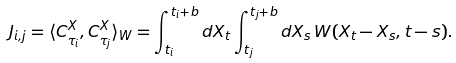<formula> <loc_0><loc_0><loc_500><loc_500>\ J _ { i , j } = \langle C ^ { X } _ { \tau _ { i } } , C ^ { X } _ { \tau _ { j } } \rangle _ { W } = \int _ { t _ { i } } ^ { t _ { i } + b } d X _ { t } \int _ { t _ { j } } ^ { t _ { j } + b } d X _ { s } \, W ( X _ { t } - X _ { s } , t - s ) .</formula> 